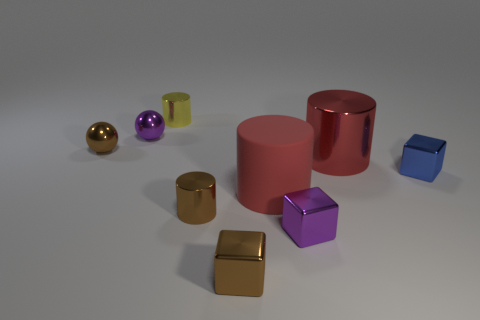Add 1 tiny metal objects. How many objects exist? 10 Subtract all blocks. How many objects are left? 6 Subtract 0 gray cylinders. How many objects are left? 9 Subtract all tiny blue rubber cubes. Subtract all big shiny cylinders. How many objects are left? 8 Add 8 blue things. How many blue things are left? 9 Add 7 matte objects. How many matte objects exist? 8 